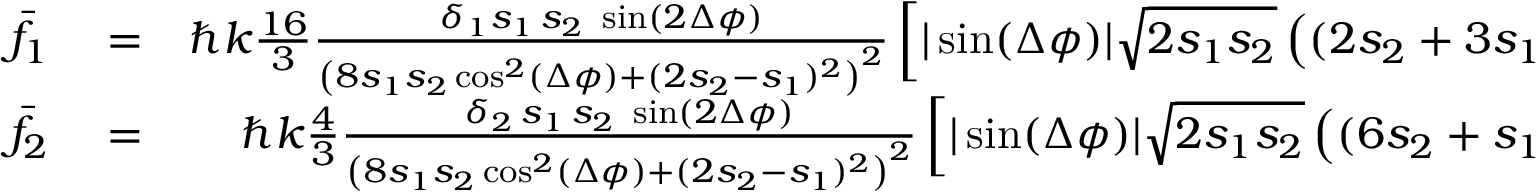Convert formula to latex. <formula><loc_0><loc_0><loc_500><loc_500>\begin{array} { r l r } { { \bar { f } } _ { 1 } } & = } & { \hbar { k } \frac { 1 6 } { 3 } \frac { \delta _ { 1 } s _ { 1 } \, s _ { 2 } \, \sin ( 2 \Delta \phi ) } { \left ( 8 s _ { 1 } s _ { 2 } \cos ^ { 2 } ( \Delta \phi ) + ( 2 s _ { 2 } - s _ { 1 } ) ^ { 2 } \right ) ^ { 2 } } \left [ | \sin ( \Delta \phi ) | \sqrt { 2 s _ { 1 } s _ { 2 } } \left ( ( 2 s _ { 2 } + 3 s _ { 1 } ) ( 2 s _ { 2 } - s _ { 1 } ) - 8 s _ { 2 } s _ { 1 } \cos ^ { 2 } ( \Delta \phi ) \right ) } \\ { { \bar { f } } _ { 2 } } & = } & { \hbar { k } \frac { 4 } { 3 } \frac { \delta _ { 2 } \, s _ { 1 } \, s _ { 2 } \, \sin ( 2 \Delta \phi ) } { \left ( 8 s _ { 1 } s _ { 2 } \cos ^ { 2 } ( \Delta \phi ) + ( 2 s _ { 2 } - s _ { 1 } ) ^ { 2 } \right ) ^ { 2 } } \left [ | \sin ( \Delta \phi ) | \sqrt { 2 s _ { 1 } s _ { 2 } } \left ( ( 6 s _ { 2 } + s _ { 1 } ) ( 2 s _ { 2 } - s _ { 1 } ) + 8 s _ { 2 } s _ { 1 } \cos ^ { 2 } ( \Delta \phi ) \right ) } \end{array}</formula> 